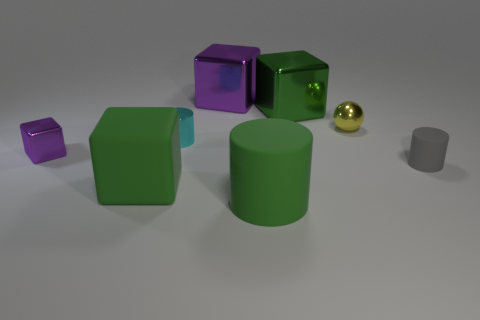Subtract all tiny cylinders. How many cylinders are left? 1 Subtract all yellow cylinders. How many purple cubes are left? 2 Add 2 tiny objects. How many objects exist? 10 Subtract all cylinders. How many objects are left? 5 Subtract all red cubes. Subtract all yellow spheres. How many cubes are left? 4 Subtract 0 green spheres. How many objects are left? 8 Subtract all brown cylinders. Subtract all large metallic cubes. How many objects are left? 6 Add 6 large purple cubes. How many large purple cubes are left? 7 Add 1 tiny green matte blocks. How many tiny green matte blocks exist? 1 